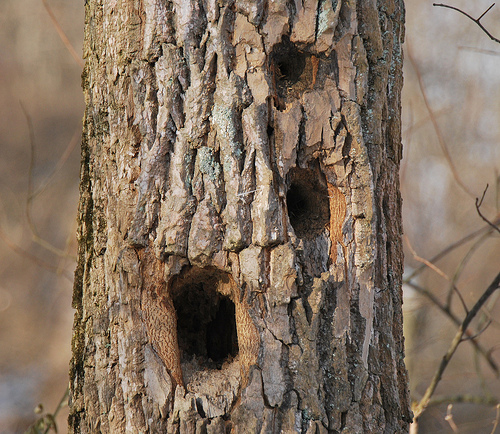<image>
Is there a hole in the bark? Yes. The hole is contained within or inside the bark, showing a containment relationship. Is the hole next to the hole? Yes. The hole is positioned adjacent to the hole, located nearby in the same general area. 